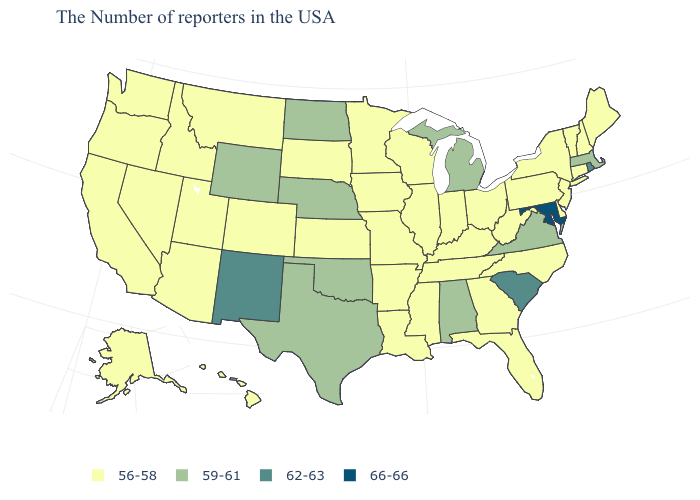What is the lowest value in the USA?
Answer briefly. 56-58. What is the value of Pennsylvania?
Keep it brief. 56-58. Name the states that have a value in the range 56-58?
Give a very brief answer. Maine, New Hampshire, Vermont, Connecticut, New York, New Jersey, Delaware, Pennsylvania, North Carolina, West Virginia, Ohio, Florida, Georgia, Kentucky, Indiana, Tennessee, Wisconsin, Illinois, Mississippi, Louisiana, Missouri, Arkansas, Minnesota, Iowa, Kansas, South Dakota, Colorado, Utah, Montana, Arizona, Idaho, Nevada, California, Washington, Oregon, Alaska, Hawaii. Does the map have missing data?
Quick response, please. No. What is the highest value in the USA?
Concise answer only. 66-66. What is the value of West Virginia?
Keep it brief. 56-58. Name the states that have a value in the range 59-61?
Give a very brief answer. Massachusetts, Virginia, Michigan, Alabama, Nebraska, Oklahoma, Texas, North Dakota, Wyoming. Among the states that border New Mexico , does Colorado have the highest value?
Quick response, please. No. Does South Dakota have the highest value in the MidWest?
Write a very short answer. No. What is the lowest value in the West?
Give a very brief answer. 56-58. What is the value of Kansas?
Answer briefly. 56-58. What is the value of Virginia?
Concise answer only. 59-61. Name the states that have a value in the range 66-66?
Write a very short answer. Maryland. What is the value of Oregon?
Short answer required. 56-58. Name the states that have a value in the range 66-66?
Be succinct. Maryland. 